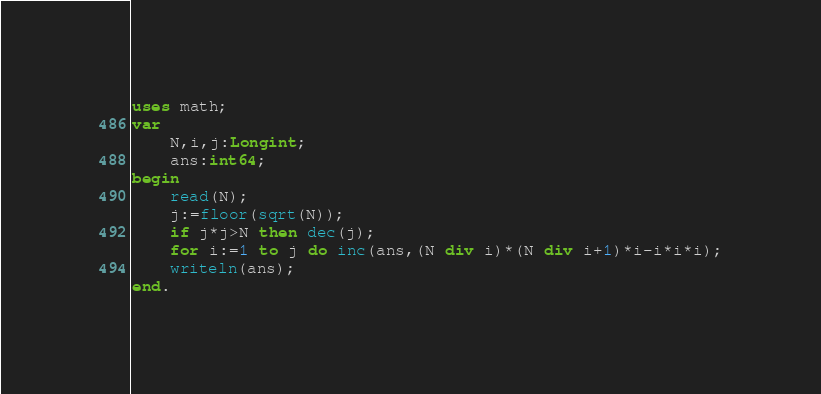Convert code to text. <code><loc_0><loc_0><loc_500><loc_500><_Pascal_>uses math;
var
	N,i,j:Longint;
	ans:int64;
begin
	read(N);
	j:=floor(sqrt(N));
	if j*j>N then dec(j);
	for i:=1 to j do inc(ans,(N div i)*(N div i+1)*i-i*i*i);
	writeln(ans);
end.</code> 